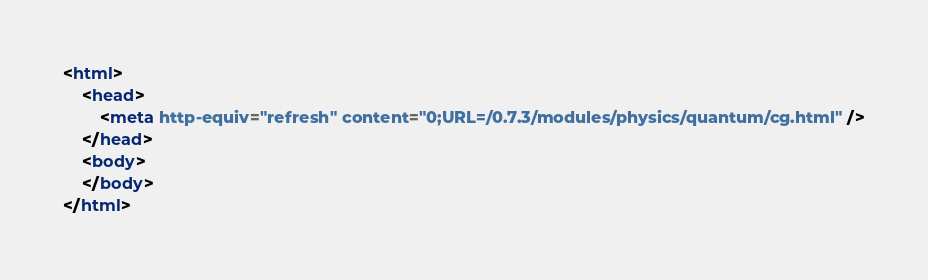<code> <loc_0><loc_0><loc_500><loc_500><_HTML_><html>
    <head>
        <meta http-equiv="refresh" content="0;URL=/0.7.3/modules/physics/quantum/cg.html" />
    </head>
    <body>
    </body>
</html>

</code> 